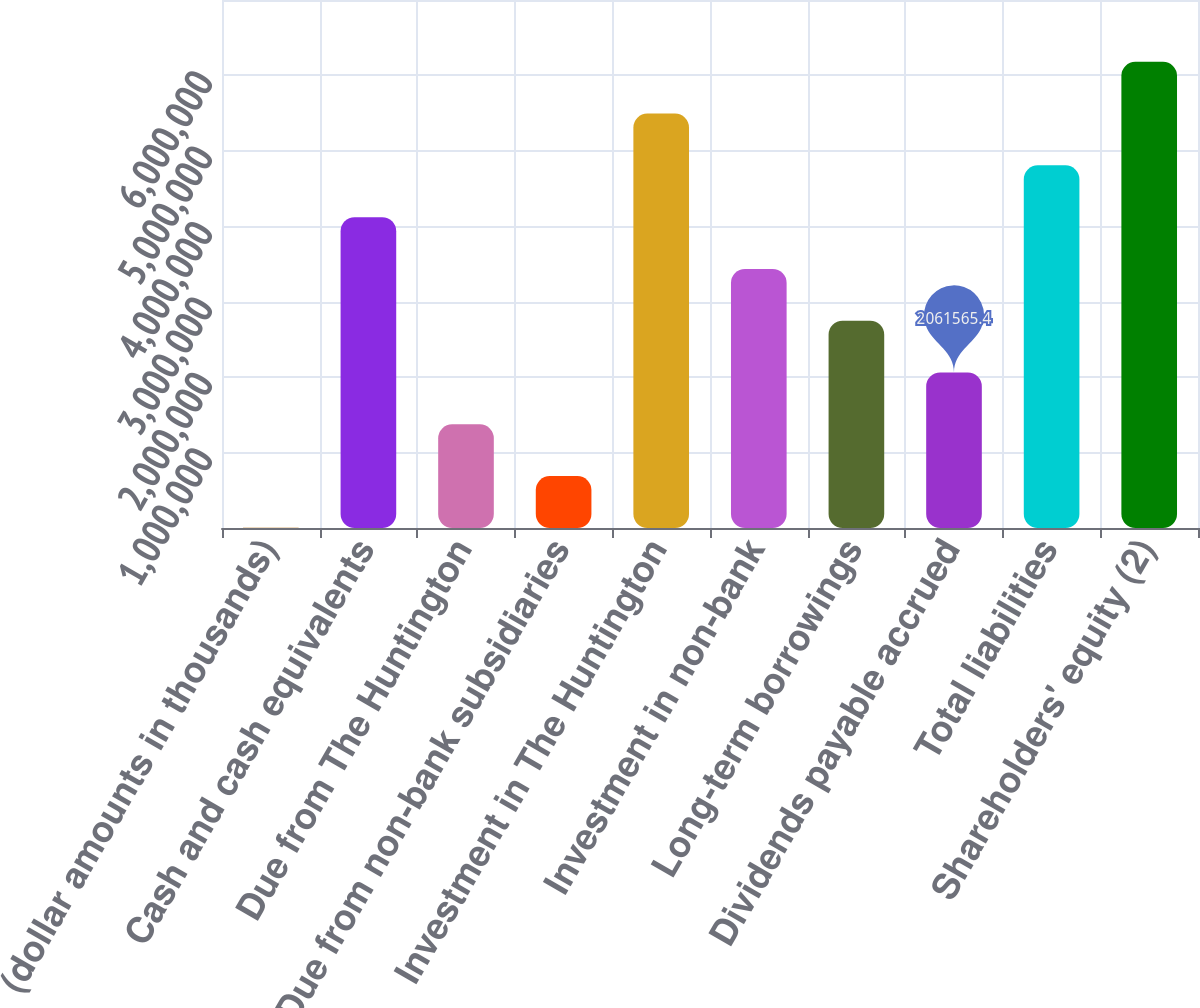Convert chart. <chart><loc_0><loc_0><loc_500><loc_500><bar_chart><fcel>(dollar amounts in thousands)<fcel>Cash and cash equivalents<fcel>Due from The Huntington<fcel>Due from non-bank subsidiaries<fcel>Investment in The Huntington<fcel>Investment in non-bank<fcel>Long-term borrowings<fcel>Dividends payable accrued<fcel>Total liabilities<fcel>Shareholders' equity (2)<nl><fcel>2012<fcel>4.12112e+06<fcel>1.37505e+06<fcel>688530<fcel>5.49415e+06<fcel>3.4346e+06<fcel>2.74808e+06<fcel>2.06157e+06<fcel>4.80764e+06<fcel>6.18067e+06<nl></chart> 